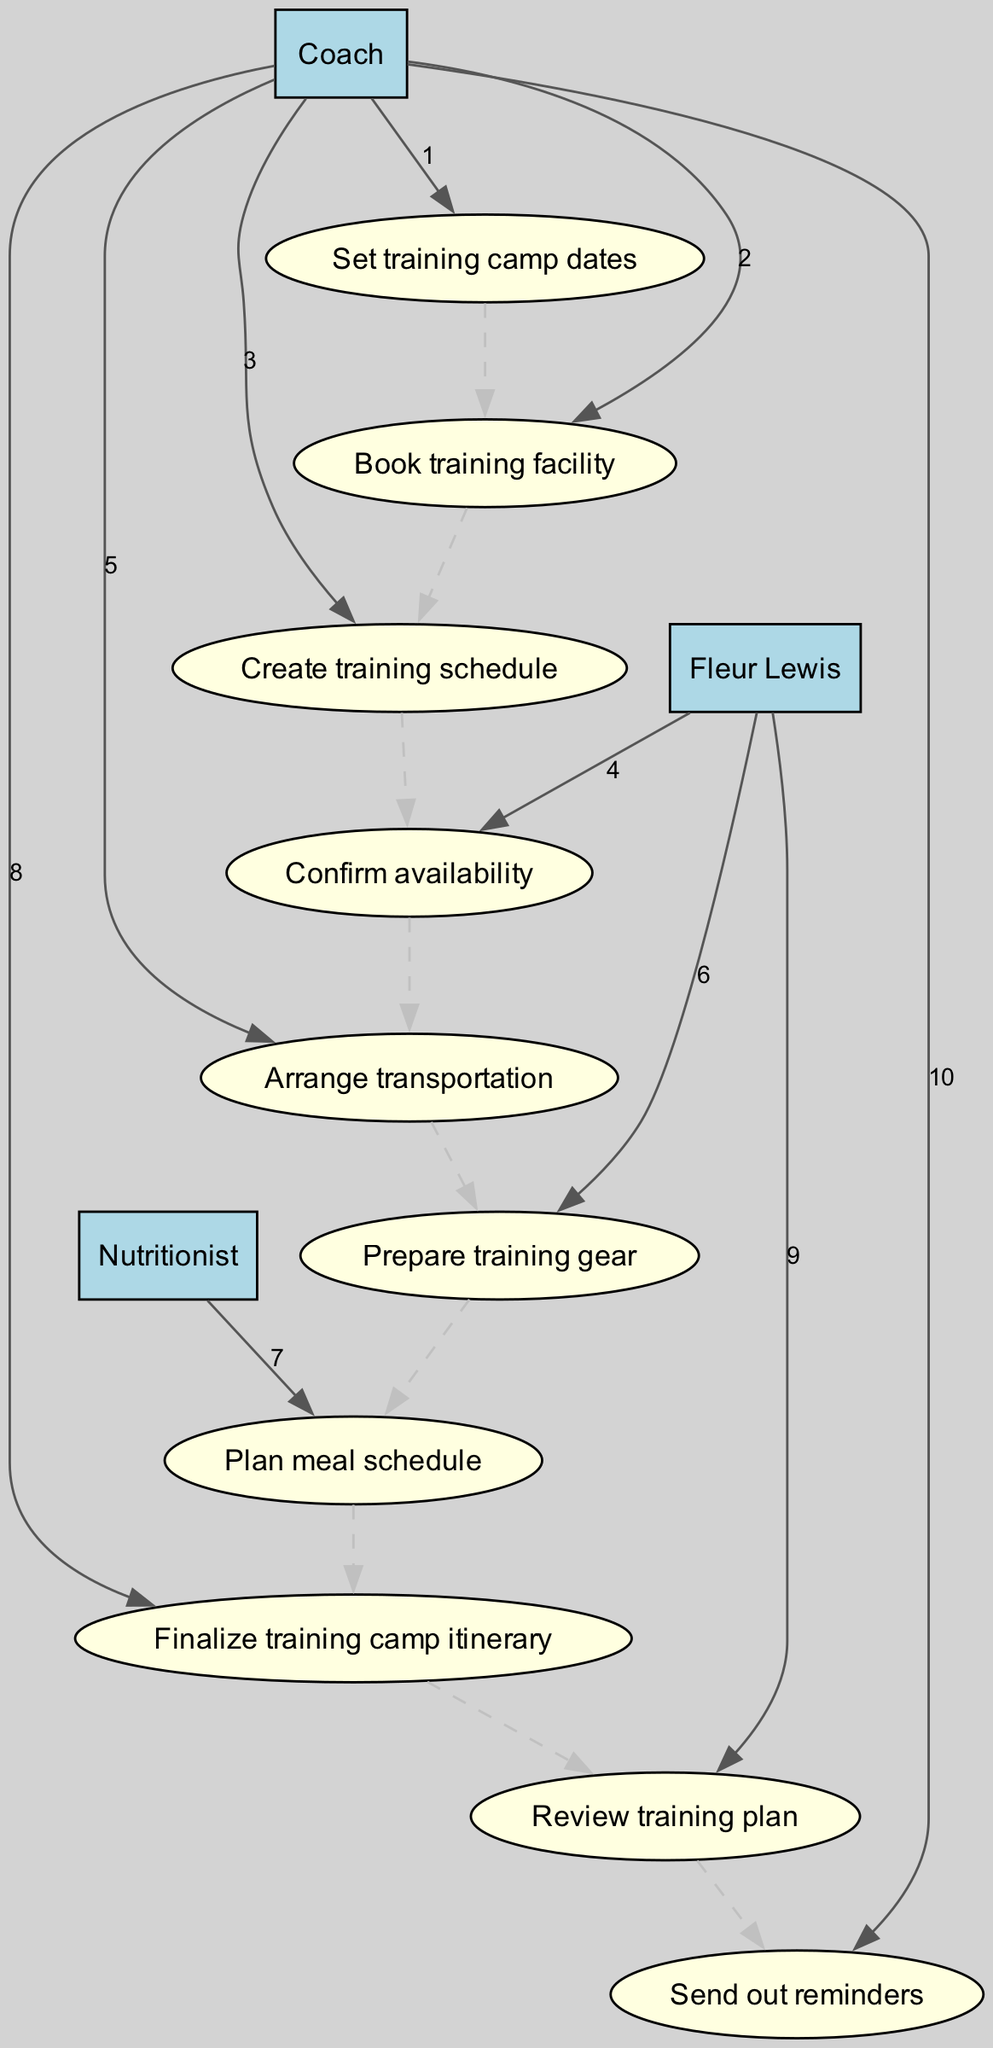What is the first action taken in the sequence? The first action corresponds to the first item in the list of actions, which is "Set training camp dates."
Answer: Set training camp dates Who is responsible for preparing the training gear? The action "Prepare training gear" is associated with Fleur Lewis, indicating she is responsible for this task.
Answer: Fleur Lewis How many total actions are represented in the diagram? By counting the number of action items listed, we find there are 9 actions in total.
Answer: 9 Which actor is involved in arranging transportation? The action "Arrange transportation" is performed by the Coach, based on its association with that actor.
Answer: Coach What action comes immediately after creating the training schedule? The action that follows "Create training schedule" in the sequence is "Confirm availability," indicating Fleur Lewis's involvement right after this step.
Answer: Confirm availability How many actors are involved in the sequence? A review of the distinct actors reveals that there are 3 participants: Coach, Fleur Lewis, and Nutritionist.
Answer: 3 What is the last action taken in the sequence? The last action recorded is "Send out reminders," which signifies the final step of the sequence.
Answer: Send out reminders What is the relationship between Fleur Lewis and the action "Review training plan"? The action "Review training plan" is performed by Fleur Lewis, establishing a direct responsibility for this task.
Answer: Fleur Lewis Which actor plans the meal schedule? The task "Plan meal schedule" is attributed to the Nutritionist, indicating who is responsible for this action.
Answer: Nutritionist 